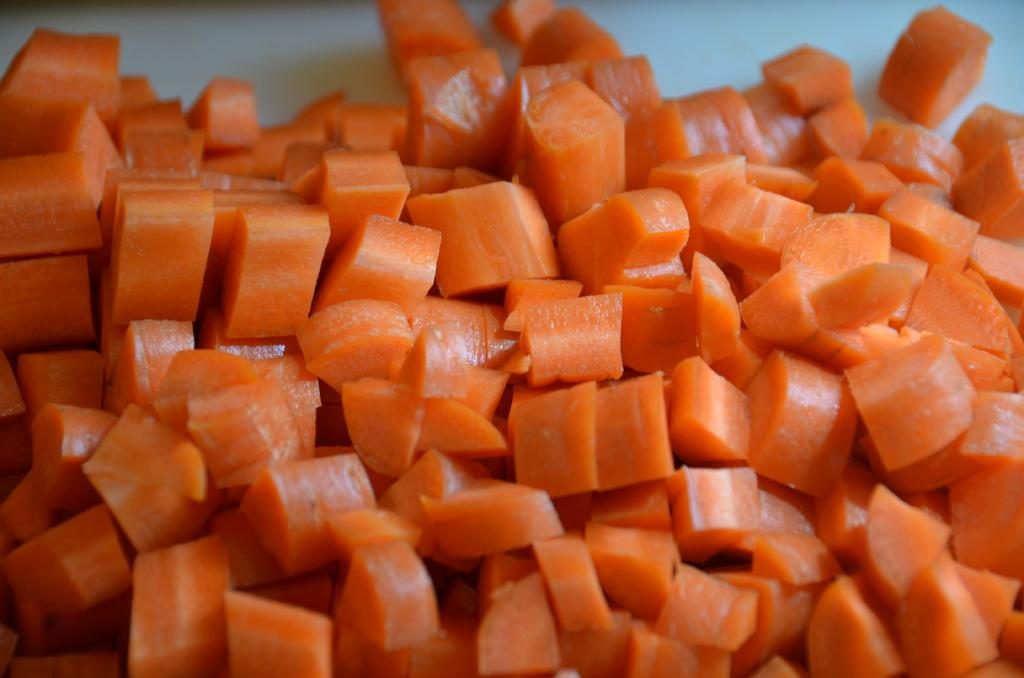What type of items can be seen in the image? The image contains food. What type of journey does the laborer take with their parent in the image? There is no journey, laborer, or parent present in the image; it only contains food. 